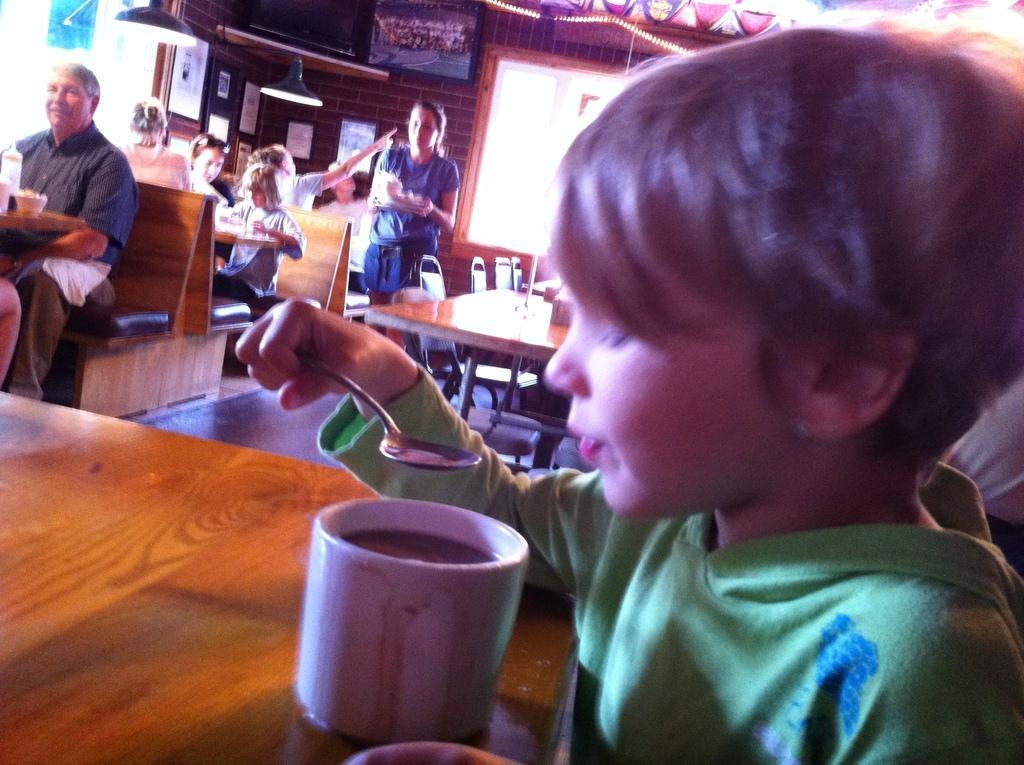How would you summarize this image in a sentence or two? In this image we can see persons sitting on the benches and a woman standing on the floor. In addition to this we can see electric lights, wall hangings, a dog, crockery, chairs and a clock. 